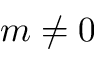<formula> <loc_0><loc_0><loc_500><loc_500>m \neq 0</formula> 